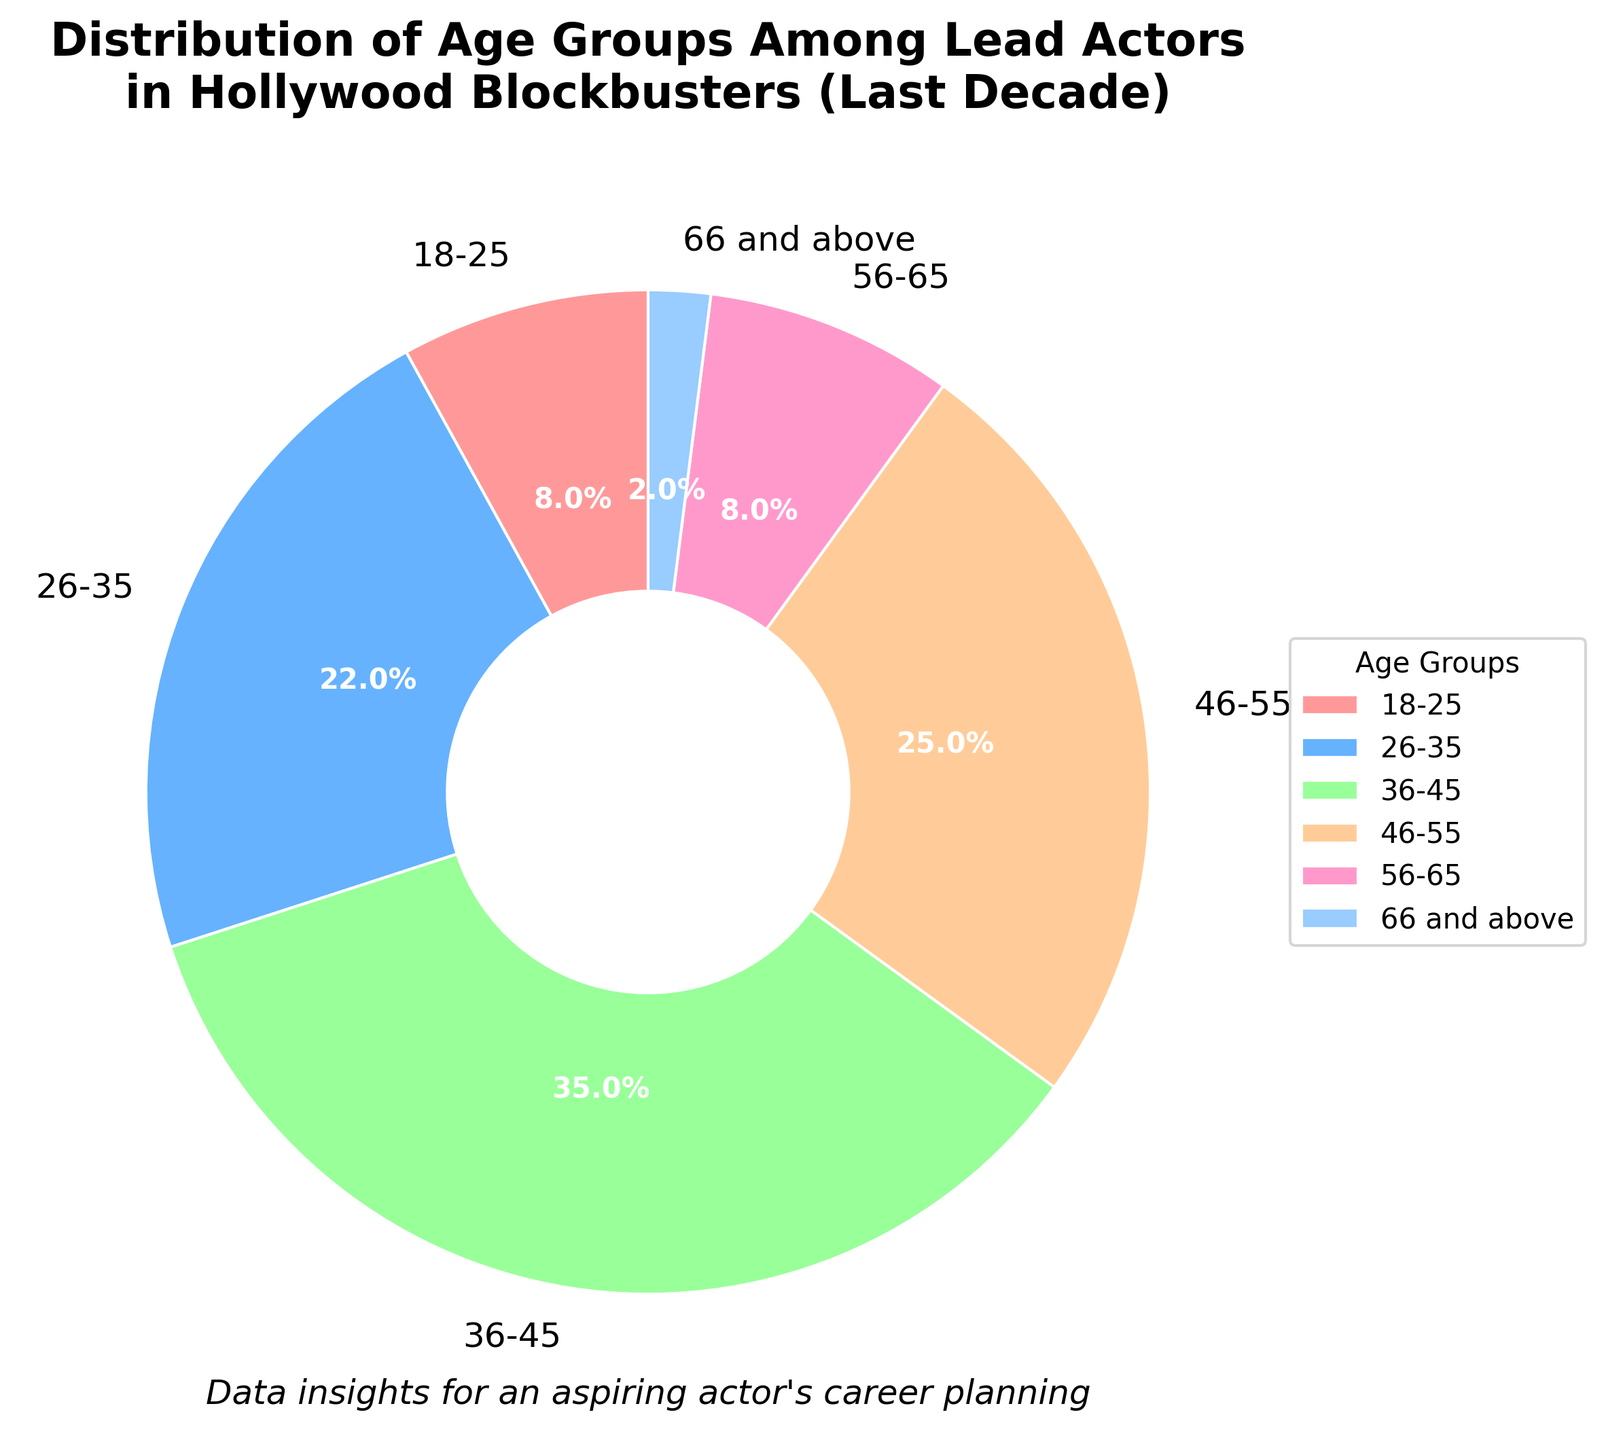What's the most common age group among lead actors in Hollywood blockbusters over the past decade? The figure shows that the age group 36-45 has the largest segment, indicating that this is the most common age group.
Answer: 36-45 Which two age groups combined represent the smallest percentage of lead actors? Adding the percentages of the age groups 66 and above (2%) and 18-25 (8%) gives a total of 10%, which is the smallest combination when compared to other age groups.
Answer: 66 and above, 18-25 How much larger is the percentage of lead actors aged 26-35 compared to those aged 56-65? By subtracting the percentage of the 56-65 age group (8%) from the 26-35 age group (22%), we get 14%.
Answer: 14% What is the combined percentage of lead actors aged 36-45 and 46-55? Adding the percentages of the 36-45 age group (35%) and the 46-55 age group (25%) gives us a total of 60%.
Answer: 60% Which age group has the second largest representation among lead actors? The age group 46-55 has the second largest segment, after the 36-45 age group.
Answer: 46-55 How does the representation of the 18-25 age group compare with the 66 and above age group? The 18-25 age group has a larger percentage (8%) than the 66 and above age group (2%).
Answer: Larger What color represents the 26-35 age group in the pie chart? The 26-35 age group is represented by the color blue in the chart.
Answer: Blue If you were to divide the age groups into younger (18-35) and older (36 and above) categories, what percentage of lead actors fall into the older category? Adding the percentages of the 36-45 (35%), 46-55 (25%), 56-65 (8%), and 66 and above (2%) age groups gives us a total of 70%.
Answer: 70% What is the visual layout used to display the distribution of the age groups? The distribution of the age groups is displayed using a pie chart, where each age group is a different segment.
Answer: Pie chart 